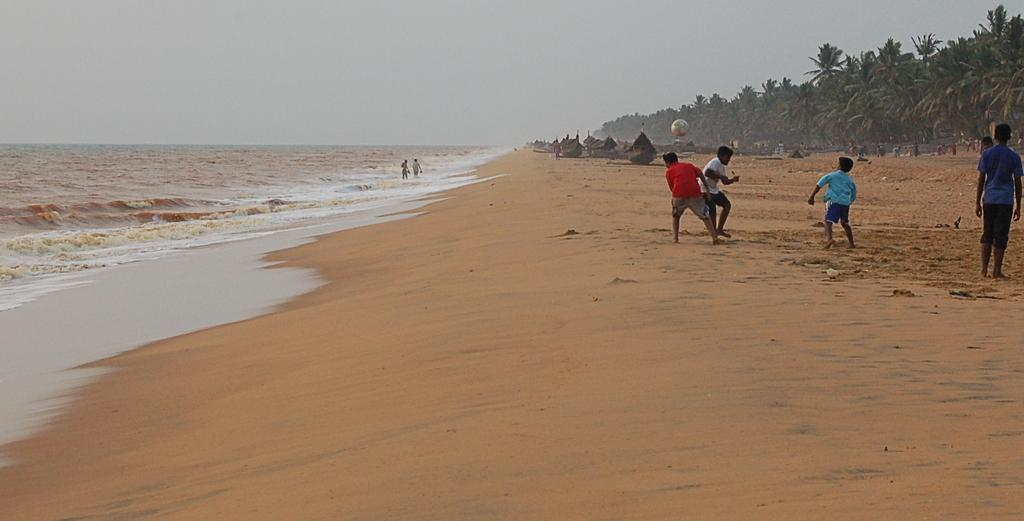How many people are in the image? There is a group of people in the image. What are some of the people doing in the image? Some people are walking in the water, while others are standing. What can be seen in the background of the image? There are boats, trees, and a ball in the background of the image. What type of wrench is being used to measure the depth of the water in the image? There is no wrench or measurement activity present in the image. 